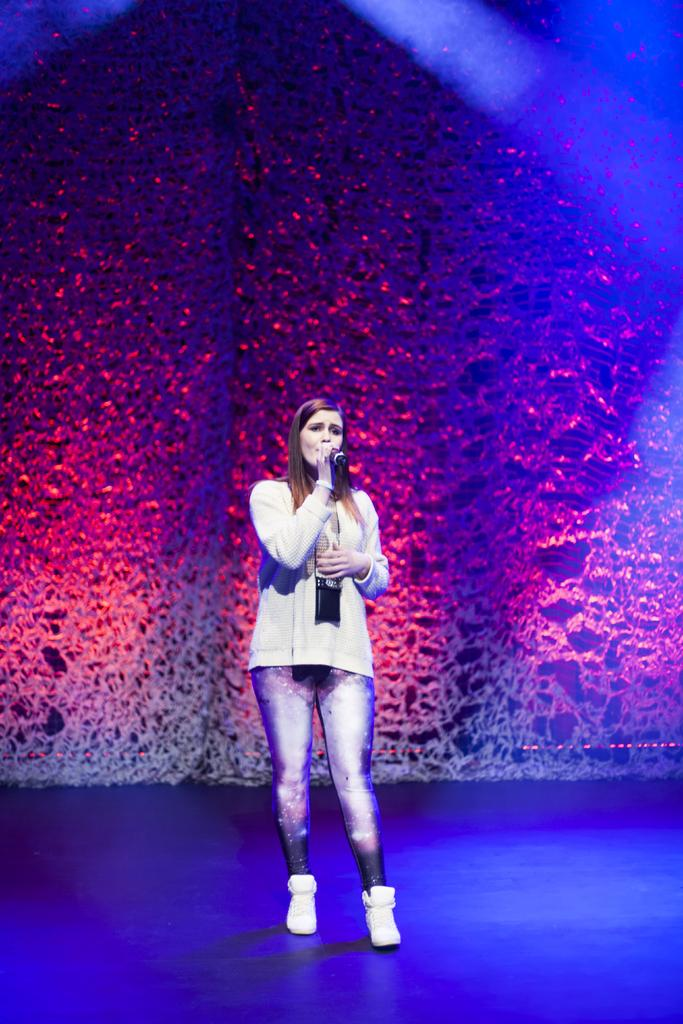Who is the main subject in the image? There is a woman in the image. What is the woman doing in the image? The woman is standing and holding a microphone. What can be seen in the background of the image? There is a curtain in the background of the image. What might the woman be doing with the microphone? The woman is speaking something, which suggests she might be giving a speech or presentation. What type of top is the woman wearing in the image? The provided facts do not mention the type of top the woman is wearing. Can you describe the woman's neck in the image? The provided facts do not mention any details about the woman's neck. 